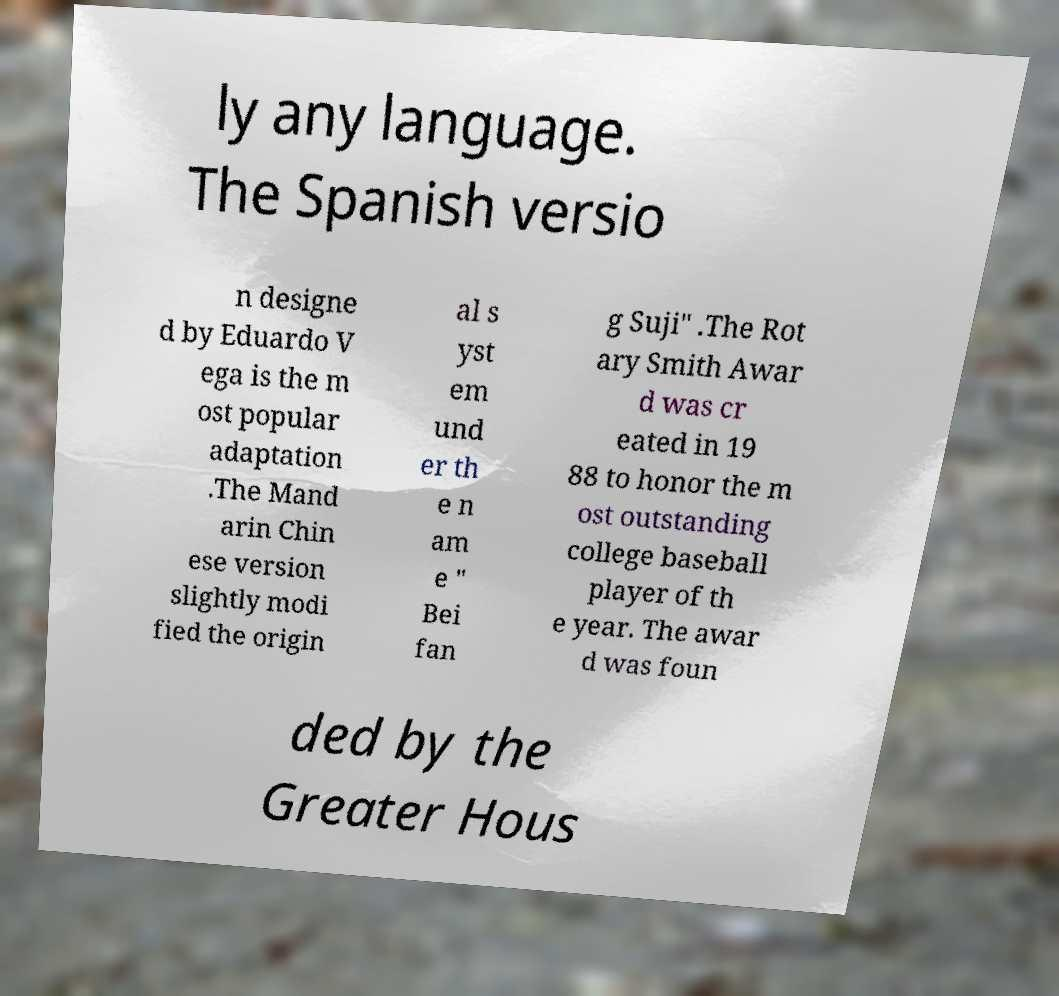Could you assist in decoding the text presented in this image and type it out clearly? ly any language. The Spanish versio n designe d by Eduardo V ega is the m ost popular adaptation .The Mand arin Chin ese version slightly modi fied the origin al s yst em und er th e n am e " Bei fan g Suji" .The Rot ary Smith Awar d was cr eated in 19 88 to honor the m ost outstanding college baseball player of th e year. The awar d was foun ded by the Greater Hous 